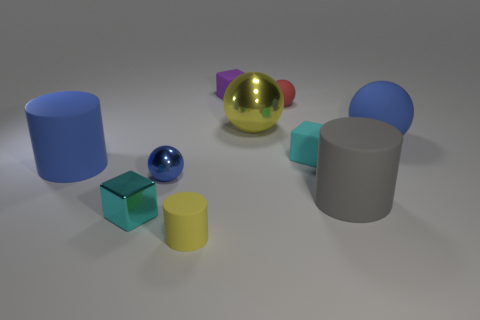Subtract all large cylinders. How many cylinders are left? 1 Subtract all gray balls. How many cyan blocks are left? 2 Subtract all yellow balls. How many balls are left? 3 Subtract 1 cubes. How many cubes are left? 2 Add 4 red matte spheres. How many red matte spheres exist? 5 Subtract 0 brown cylinders. How many objects are left? 10 Subtract all balls. How many objects are left? 6 Subtract all yellow cubes. Subtract all yellow spheres. How many cubes are left? 3 Subtract all red objects. Subtract all tiny green metal cubes. How many objects are left? 9 Add 8 small rubber balls. How many small rubber balls are left? 9 